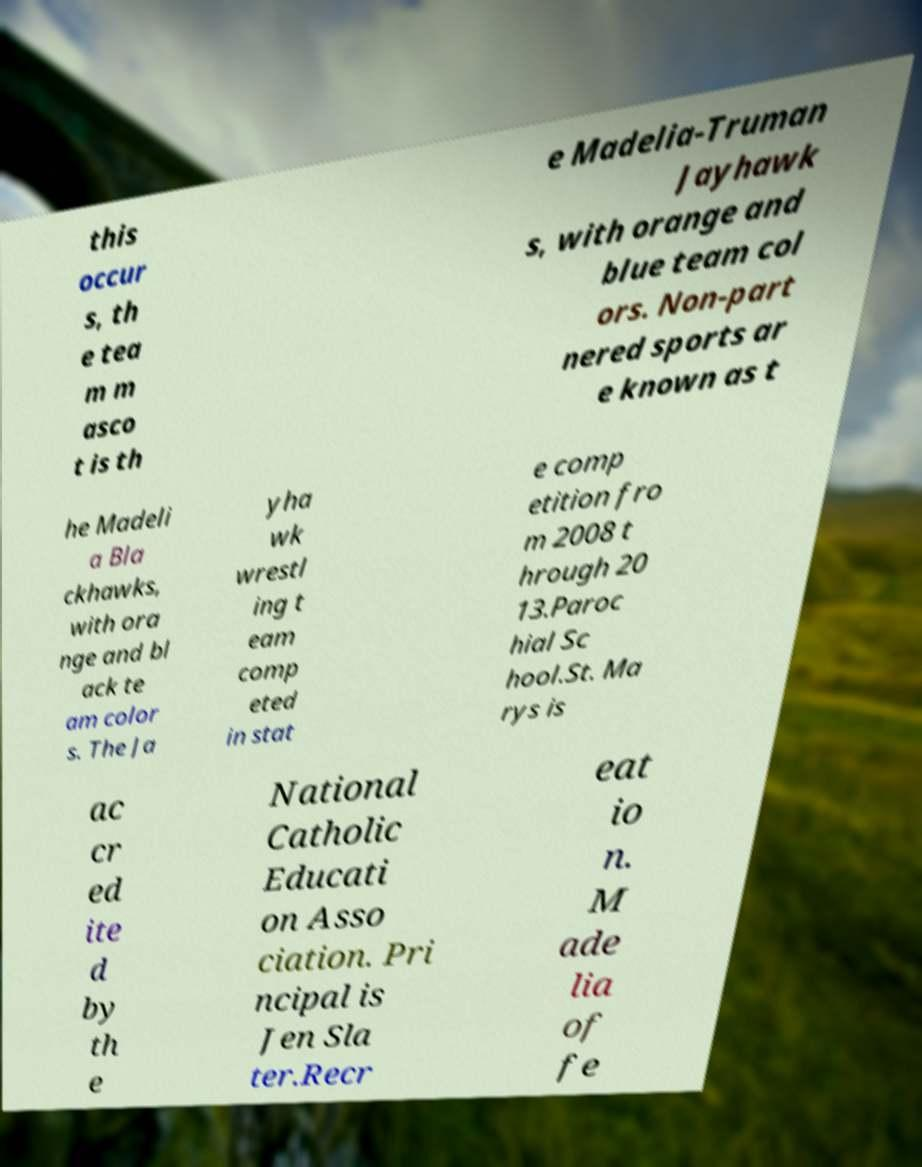I need the written content from this picture converted into text. Can you do that? this occur s, th e tea m m asco t is th e Madelia-Truman Jayhawk s, with orange and blue team col ors. Non-part nered sports ar e known as t he Madeli a Bla ckhawks, with ora nge and bl ack te am color s. The Ja yha wk wrestl ing t eam comp eted in stat e comp etition fro m 2008 t hrough 20 13.Paroc hial Sc hool.St. Ma rys is ac cr ed ite d by th e National Catholic Educati on Asso ciation. Pri ncipal is Jen Sla ter.Recr eat io n. M ade lia of fe 